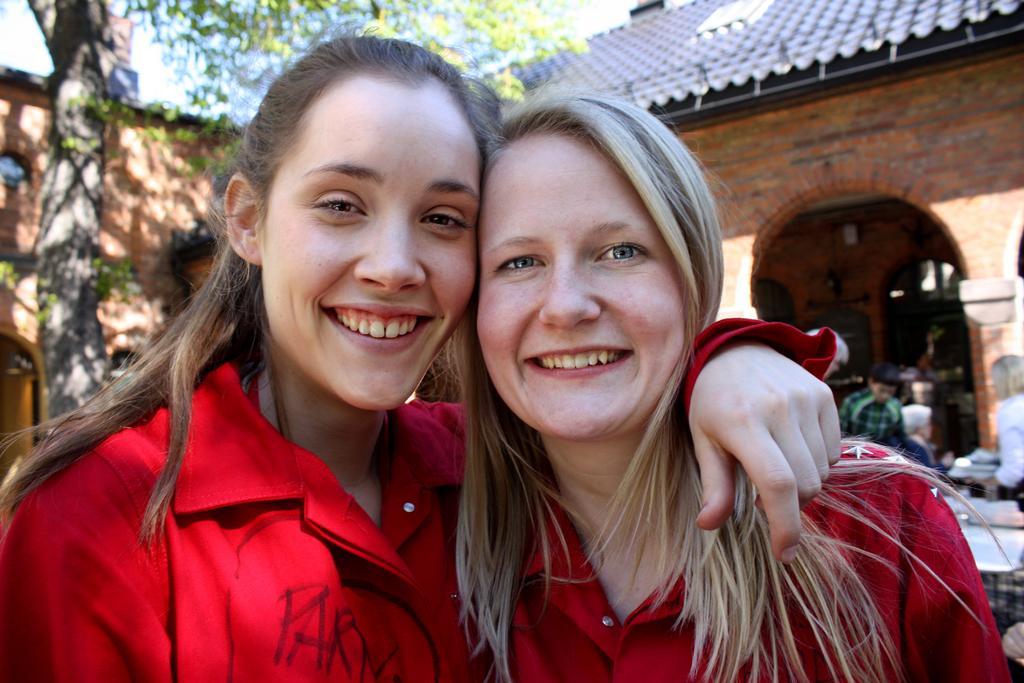Please provide a concise description of this image. In the picture we can see two women are standing together and smiling, they are in red shirts and behind them, we can see a tree and behind it, we can see some house building under it we can see some person is standing near it and on the top of the house we can see a part of the sky. 